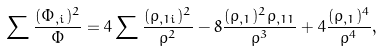<formula> <loc_0><loc_0><loc_500><loc_500>\sum \frac { ( \Phi _ { , i } ) ^ { 2 } } { \Phi } = 4 \sum \frac { ( \rho _ { , 1 i } ) ^ { 2 } } { \rho ^ { 2 } } - 8 \frac { ( \rho _ { , 1 } ) ^ { 2 } \rho _ { , 1 1 } } { \rho ^ { 3 } } + 4 \frac { ( \rho _ { , 1 } ) ^ { 4 } } { \rho ^ { 4 } } ,</formula> 